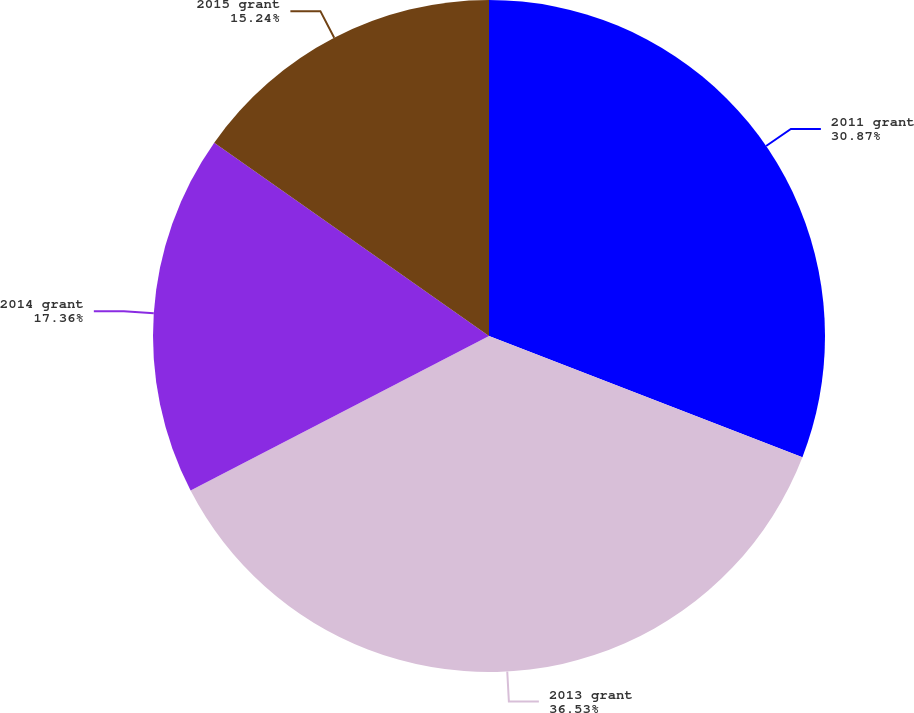<chart> <loc_0><loc_0><loc_500><loc_500><pie_chart><fcel>2011 grant<fcel>2013 grant<fcel>2014 grant<fcel>2015 grant<nl><fcel>30.87%<fcel>36.53%<fcel>17.36%<fcel>15.24%<nl></chart> 